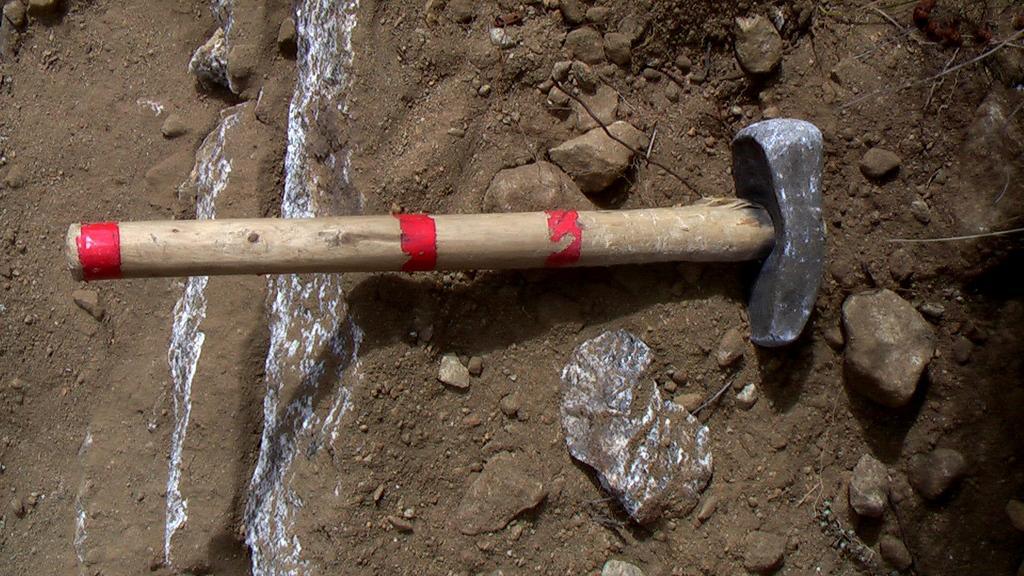Could you give a brief overview of what you see in this image? In this picture we can observe a hammer. There are some stones on the ground. We can observe small stones here. 